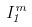Convert formula to latex. <formula><loc_0><loc_0><loc_500><loc_500>I _ { 1 } ^ { m }</formula> 